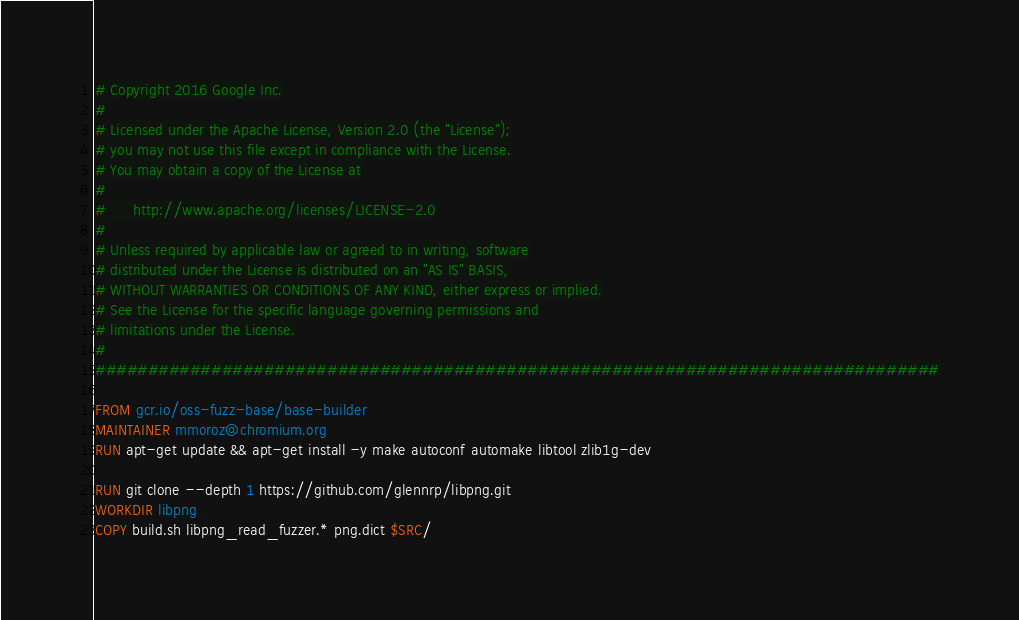Convert code to text. <code><loc_0><loc_0><loc_500><loc_500><_Dockerfile_># Copyright 2016 Google Inc.
#
# Licensed under the Apache License, Version 2.0 (the "License");
# you may not use this file except in compliance with the License.
# You may obtain a copy of the License at
#
#      http://www.apache.org/licenses/LICENSE-2.0
#
# Unless required by applicable law or agreed to in writing, software
# distributed under the License is distributed on an "AS IS" BASIS,
# WITHOUT WARRANTIES OR CONDITIONS OF ANY KIND, either express or implied.
# See the License for the specific language governing permissions and
# limitations under the License.
#
################################################################################

FROM gcr.io/oss-fuzz-base/base-builder
MAINTAINER mmoroz@chromium.org
RUN apt-get update && apt-get install -y make autoconf automake libtool zlib1g-dev

RUN git clone --depth 1 https://github.com/glennrp/libpng.git
WORKDIR libpng
COPY build.sh libpng_read_fuzzer.* png.dict $SRC/
</code> 